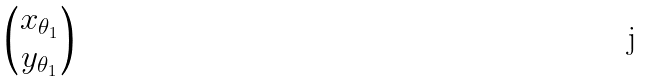<formula> <loc_0><loc_0><loc_500><loc_500>\begin{pmatrix} x _ { \theta _ { 1 } } \\ y _ { \theta _ { 1 } } \end{pmatrix}</formula> 